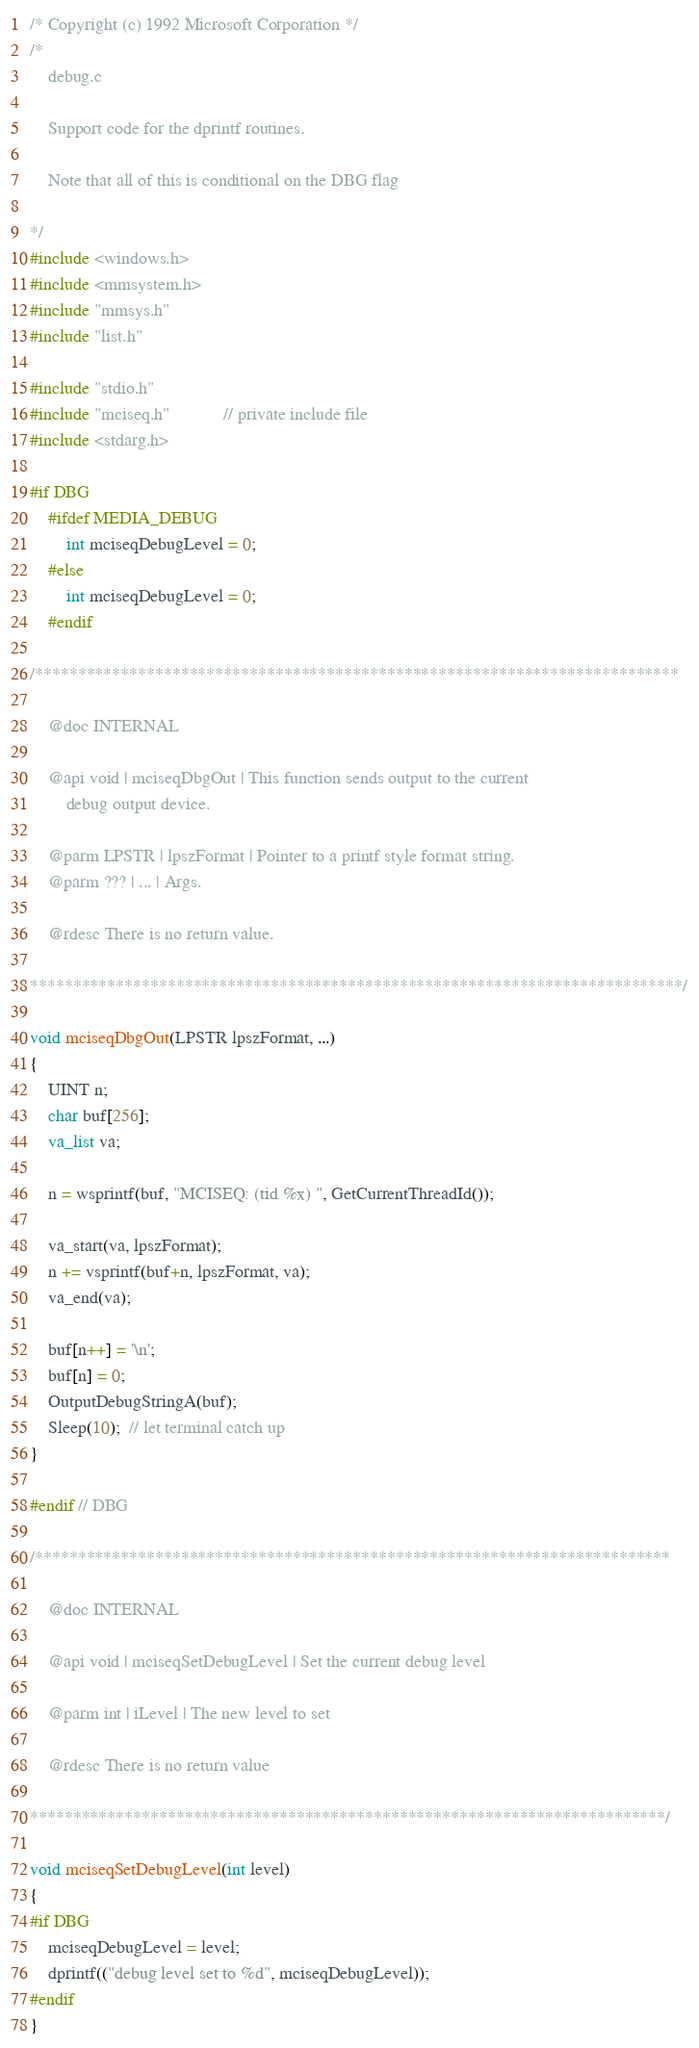Convert code to text. <code><loc_0><loc_0><loc_500><loc_500><_C_>/* Copyright (c) 1992 Microsoft Corporation */
/*
    debug.c

    Support code for the dprintf routines.

    Note that all of this is conditional on the DBG flag

*/
#include <windows.h>
#include <mmsystem.h>
#include "mmsys.h"
#include "list.h"

#include "stdio.h"
#include "mciseq.h"            // private include file
#include <stdarg.h>

#if DBG
    #ifdef MEDIA_DEBUG
        int mciseqDebugLevel = 0;
    #else
        int mciseqDebugLevel = 0;
    #endif

/***************************************************************************

    @doc INTERNAL

    @api void | mciseqDbgOut | This function sends output to the current
        debug output device.

    @parm LPSTR | lpszFormat | Pointer to a printf style format string.
    @parm ??? | ... | Args.

    @rdesc There is no return value.

****************************************************************************/

void mciseqDbgOut(LPSTR lpszFormat, ...)
{
    UINT n;
    char buf[256];
    va_list va;

    n = wsprintf(buf, "MCISEQ: (tid %x) ", GetCurrentThreadId());

    va_start(va, lpszFormat);
    n += vsprintf(buf+n, lpszFormat, va);
    va_end(va);

    buf[n++] = '\n';
    buf[n] = 0;
    OutputDebugStringA(buf);
    Sleep(10);  // let terminal catch up
}

#endif // DBG

/**************************************************************************

    @doc INTERNAL

    @api void | mciseqSetDebugLevel | Set the current debug level

    @parm int | iLevel | The new level to set

    @rdesc There is no return value

**************************************************************************/

void mciseqSetDebugLevel(int level)
{
#if DBG
    mciseqDebugLevel = level;
    dprintf(("debug level set to %d", mciseqDebugLevel));
#endif
}
</code> 